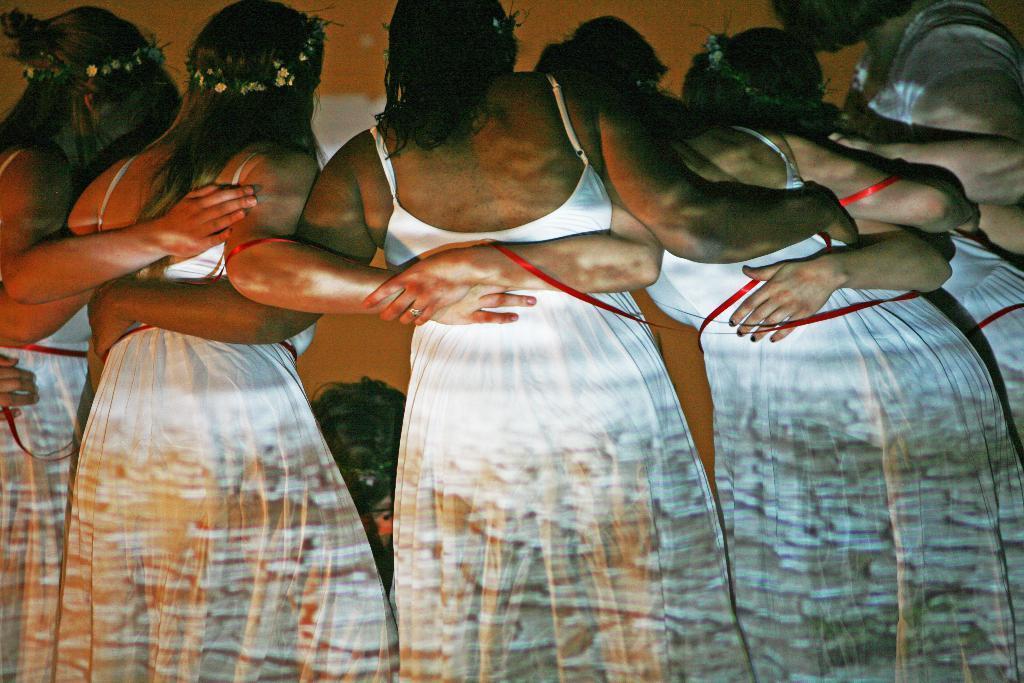Can you describe this image briefly? In this image we can see six women are standing. They are wearing white color dress and tiara on their head. 